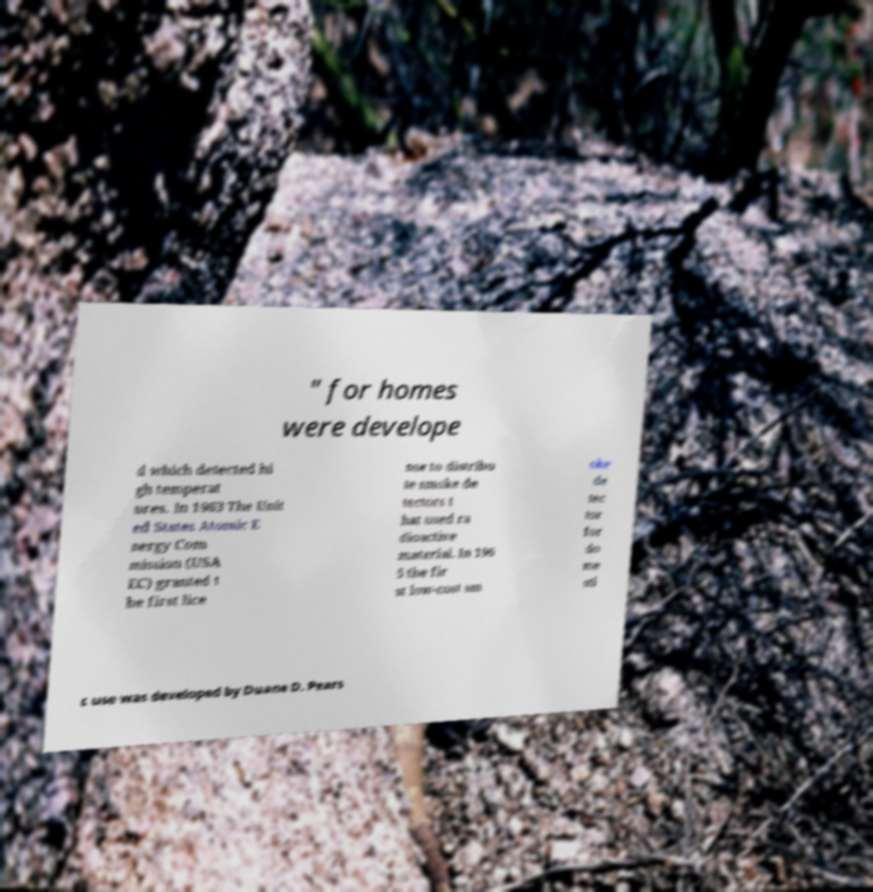Please read and relay the text visible in this image. What does it say? " for homes were develope d which detected hi gh temperat ures. In 1963 The Unit ed States Atomic E nergy Com mission (USA EC) granted t he first lice nse to distribu te smoke de tectors t hat used ra dioactive material. In 196 5 the fir st low-cost sm oke de tec tor for do me sti c use was developed by Duane D. Pears 